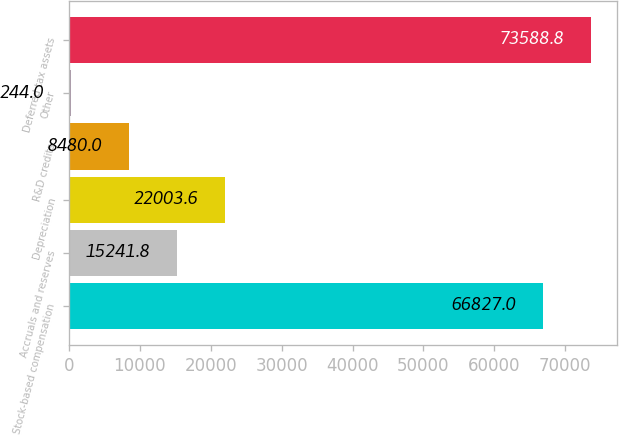Convert chart to OTSL. <chart><loc_0><loc_0><loc_500><loc_500><bar_chart><fcel>Stock-based compensation<fcel>Accruals and reserves<fcel>Depreciation<fcel>R&D credits<fcel>Other<fcel>Deferred tax assets<nl><fcel>66827<fcel>15241.8<fcel>22003.6<fcel>8480<fcel>244<fcel>73588.8<nl></chart> 